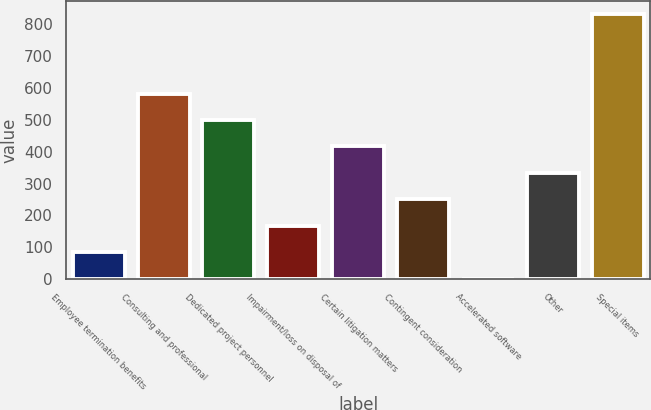Convert chart. <chart><loc_0><loc_0><loc_500><loc_500><bar_chart><fcel>Employee termination benefits<fcel>Consulting and professional<fcel>Dedicated project personnel<fcel>Impairment/loss on disposal of<fcel>Certain litigation matters<fcel>Contingent consideration<fcel>Accelerated software<fcel>Other<fcel>Special items<nl><fcel>84.53<fcel>582.71<fcel>499.68<fcel>167.56<fcel>416.65<fcel>250.59<fcel>1.5<fcel>333.62<fcel>831.8<nl></chart> 